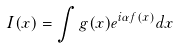Convert formula to latex. <formula><loc_0><loc_0><loc_500><loc_500>I ( x ) = \int g ( x ) e ^ { i \alpha f ( x ) } d x</formula> 